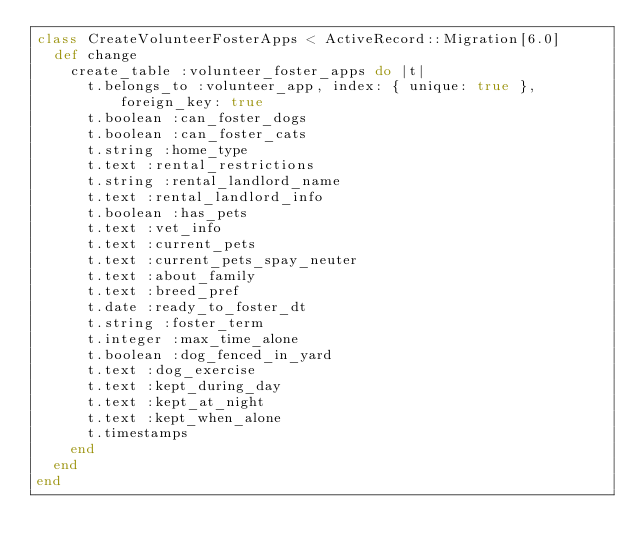<code> <loc_0><loc_0><loc_500><loc_500><_Ruby_>class CreateVolunteerFosterApps < ActiveRecord::Migration[6.0]
  def change
    create_table :volunteer_foster_apps do |t|
      t.belongs_to :volunteer_app, index: { unique: true }, foreign_key: true
      t.boolean :can_foster_dogs
      t.boolean :can_foster_cats
      t.string :home_type
      t.text :rental_restrictions
      t.string :rental_landlord_name
      t.text :rental_landlord_info
      t.boolean :has_pets
      t.text :vet_info
      t.text :current_pets
      t.text :current_pets_spay_neuter
      t.text :about_family
      t.text :breed_pref
      t.date :ready_to_foster_dt
      t.string :foster_term
      t.integer :max_time_alone
      t.boolean :dog_fenced_in_yard
      t.text :dog_exercise
      t.text :kept_during_day
      t.text :kept_at_night
      t.text :kept_when_alone
      t.timestamps
    end
  end
end
</code> 